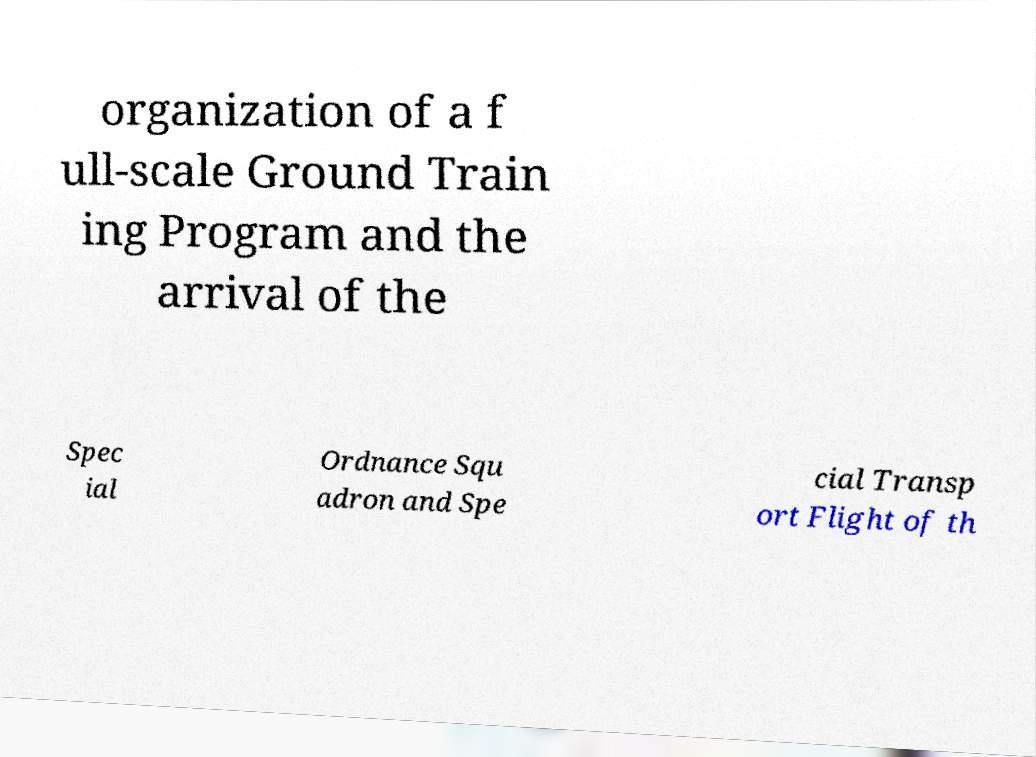I need the written content from this picture converted into text. Can you do that? organization of a f ull-scale Ground Train ing Program and the arrival of the Spec ial Ordnance Squ adron and Spe cial Transp ort Flight of th 